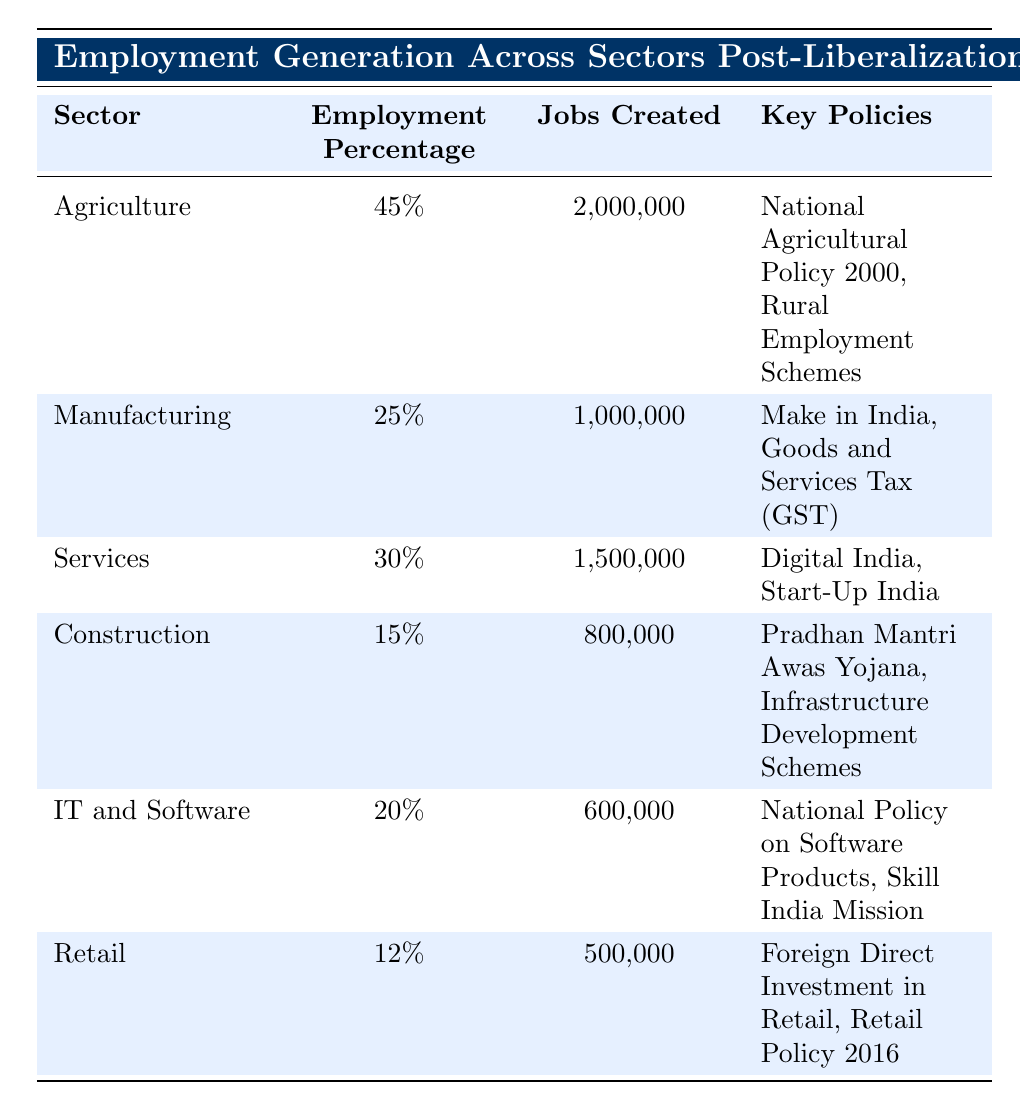What percentage of jobs were created in the agriculture sector? The table indicates that 2,000,000 jobs were created in the agriculture sector, accounting for an employment percentage of 45%.
Answer: 45% Which sector created the least number of jobs? From the data, the retail sector created 500,000 jobs, which is the least among all the sectors listed in the table.
Answer: Retail What are the key policies associated with the services sector? The table lists "Digital India" and "Start-Up India" as the key policies that correspond to the services sector.
Answer: Digital India, Start-Up India If you combine the number of jobs created in construction and retail, how many jobs are created in total? The number of jobs created in construction is 800,000 and in retail is 500,000. Combining these gives us 800,000 + 500,000 = 1,300,000 jobs.
Answer: 1,300,000 Is the employment percentage for IT and Software higher than that for Construction? The employment percentage for IT and Software is 20% and for Construction, it is 15%. Since 20% is greater than 15%, the statement is true.
Answer: Yes What is the total percentage of employment generated by the manufacturing and services sectors combined? The employment percentage for manufacturing is 25% and for services is 30%. Combining these gives us 25% + 30% = 55%.
Answer: 55% What percentage of jobs created belongs to the agriculture sector compared to the total number of jobs created across all sectors? The total number of jobs created across all sectors is 2,000,000 (Agriculture) + 1,000,000 (Manufacturing) + 1,500,000 (Services) + 800,000 (Construction) + 600,000 (IT and Software) + 500,000 (Retail) = 6,400,000. Therefore, agriculture’s share is (2,000,000 / 6,400,000) * 100 = 31.25%.
Answer: 31.25% Which sector saw a higher employment generation: Services or IT and Software? The services sector created 1,500,000 jobs while the IT and Software sector created 600,000 jobs. Since 1,500,000 is greater than 600,000, services had higher employment generation.
Answer: Services What key policy is associated with the manufacturing sector? The table identifies "Make in India" and "Goods and Services Tax (GST)" as the key policies linked to the manufacturing sector.
Answer: Make in India, Goods and Services Tax (GST) 